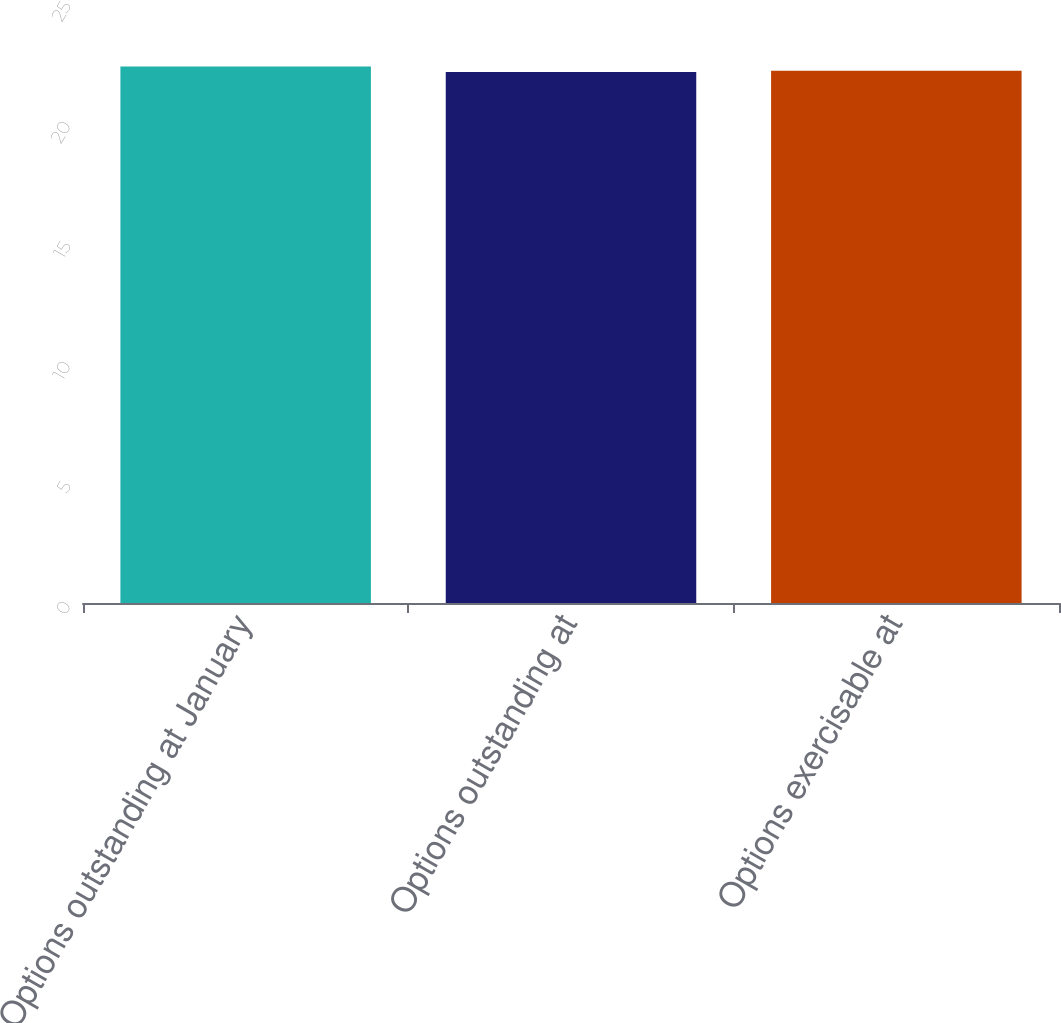Convert chart. <chart><loc_0><loc_0><loc_500><loc_500><bar_chart><fcel>Options outstanding at January<fcel>Options outstanding at<fcel>Options exercisable at<nl><fcel>22.35<fcel>22.12<fcel>22.18<nl></chart> 